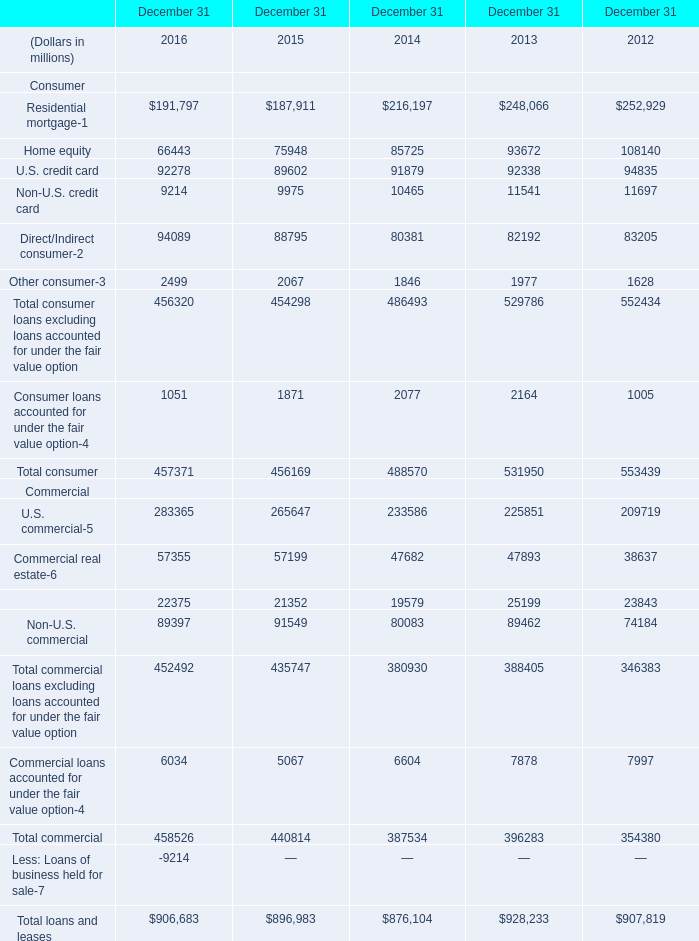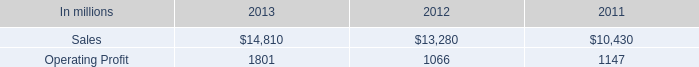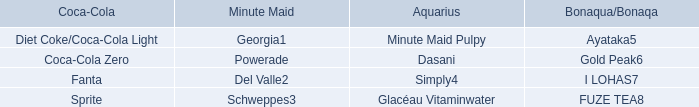Which year is Direct/Indirect consumer the most? (in millions) 
Answer: 2016. 